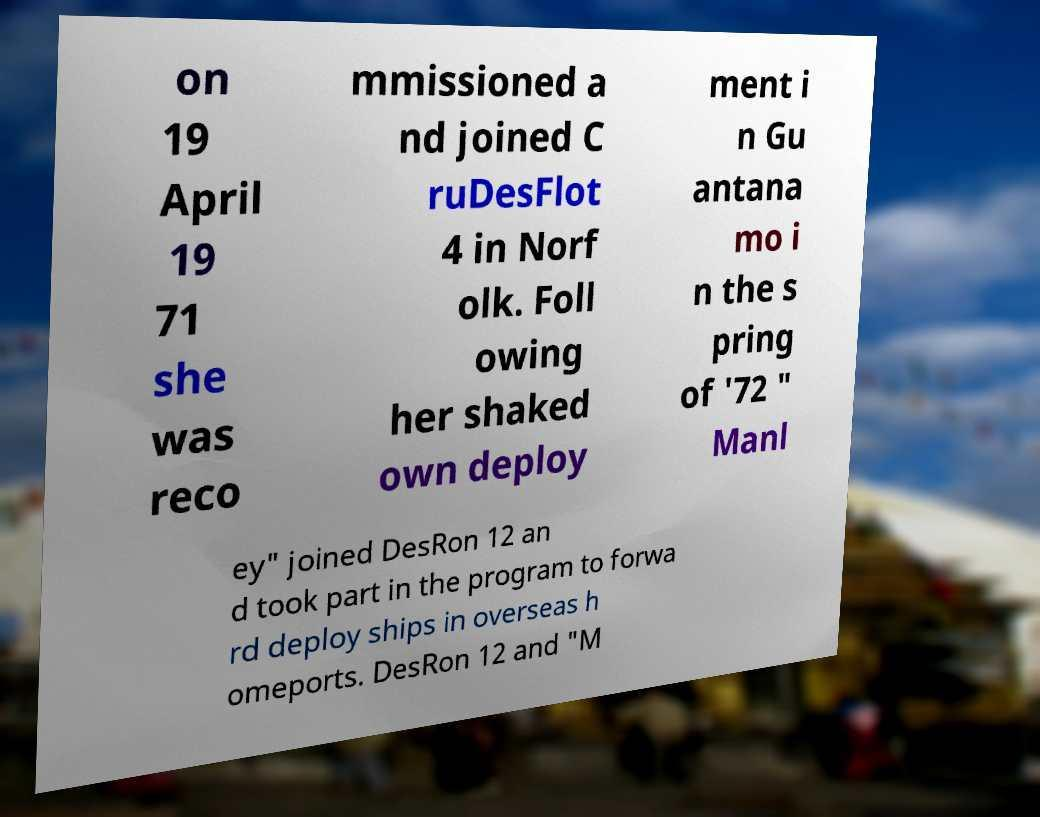Can you accurately transcribe the text from the provided image for me? on 19 April 19 71 she was reco mmissioned a nd joined C ruDesFlot 4 in Norf olk. Foll owing her shaked own deploy ment i n Gu antana mo i n the s pring of '72 " Manl ey" joined DesRon 12 an d took part in the program to forwa rd deploy ships in overseas h omeports. DesRon 12 and "M 